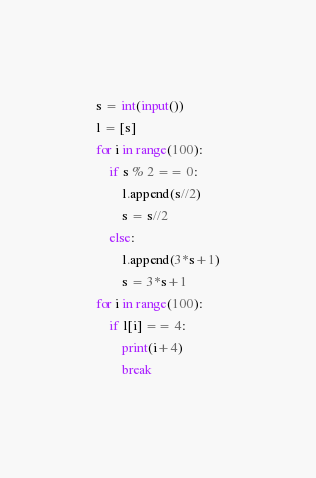Convert code to text. <code><loc_0><loc_0><loc_500><loc_500><_Python_>s = int(input())
l = [s]
for i in range(100):
    if s % 2 == 0:
        l.append(s//2)
        s = s//2
    else:
        l.append(3*s+1)
        s = 3*s+1
for i in range(100):
    if l[i] == 4:
        print(i+4)
        break</code> 